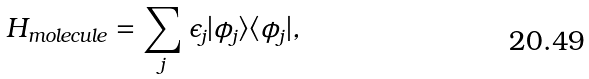<formula> <loc_0><loc_0><loc_500><loc_500>H _ { m o l e c u l e } = \sum _ { j } \epsilon _ { j } | \phi _ { j } \rangle \langle \phi _ { j } | ,</formula> 